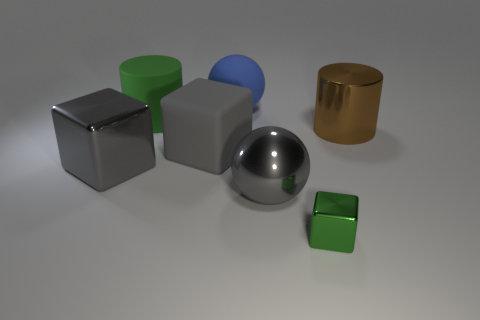How big is the block that is right of the big green matte cylinder and in front of the gray rubber object?
Provide a short and direct response. Small. Are there any shiny cubes in front of the big gray metallic thing left of the big green matte cylinder?
Ensure brevity in your answer.  Yes. What number of large matte things are behind the tiny green metal cube?
Offer a terse response. 3. There is another large thing that is the same shape as the blue rubber thing; what color is it?
Give a very brief answer. Gray. Do the cylinder that is on the right side of the large blue matte object and the gray block that is in front of the large gray matte block have the same material?
Keep it short and to the point. Yes. Is the color of the big matte block the same as the metal block to the left of the small shiny block?
Give a very brief answer. Yes. There is a gray thing that is behind the metallic ball and on the right side of the green rubber object; what shape is it?
Provide a short and direct response. Cube. How many small green metal blocks are there?
Your answer should be compact. 1. The other thing that is the same color as the small object is what shape?
Offer a very short reply. Cylinder. There is a green metal thing that is the same shape as the big gray matte thing; what size is it?
Offer a terse response. Small. 